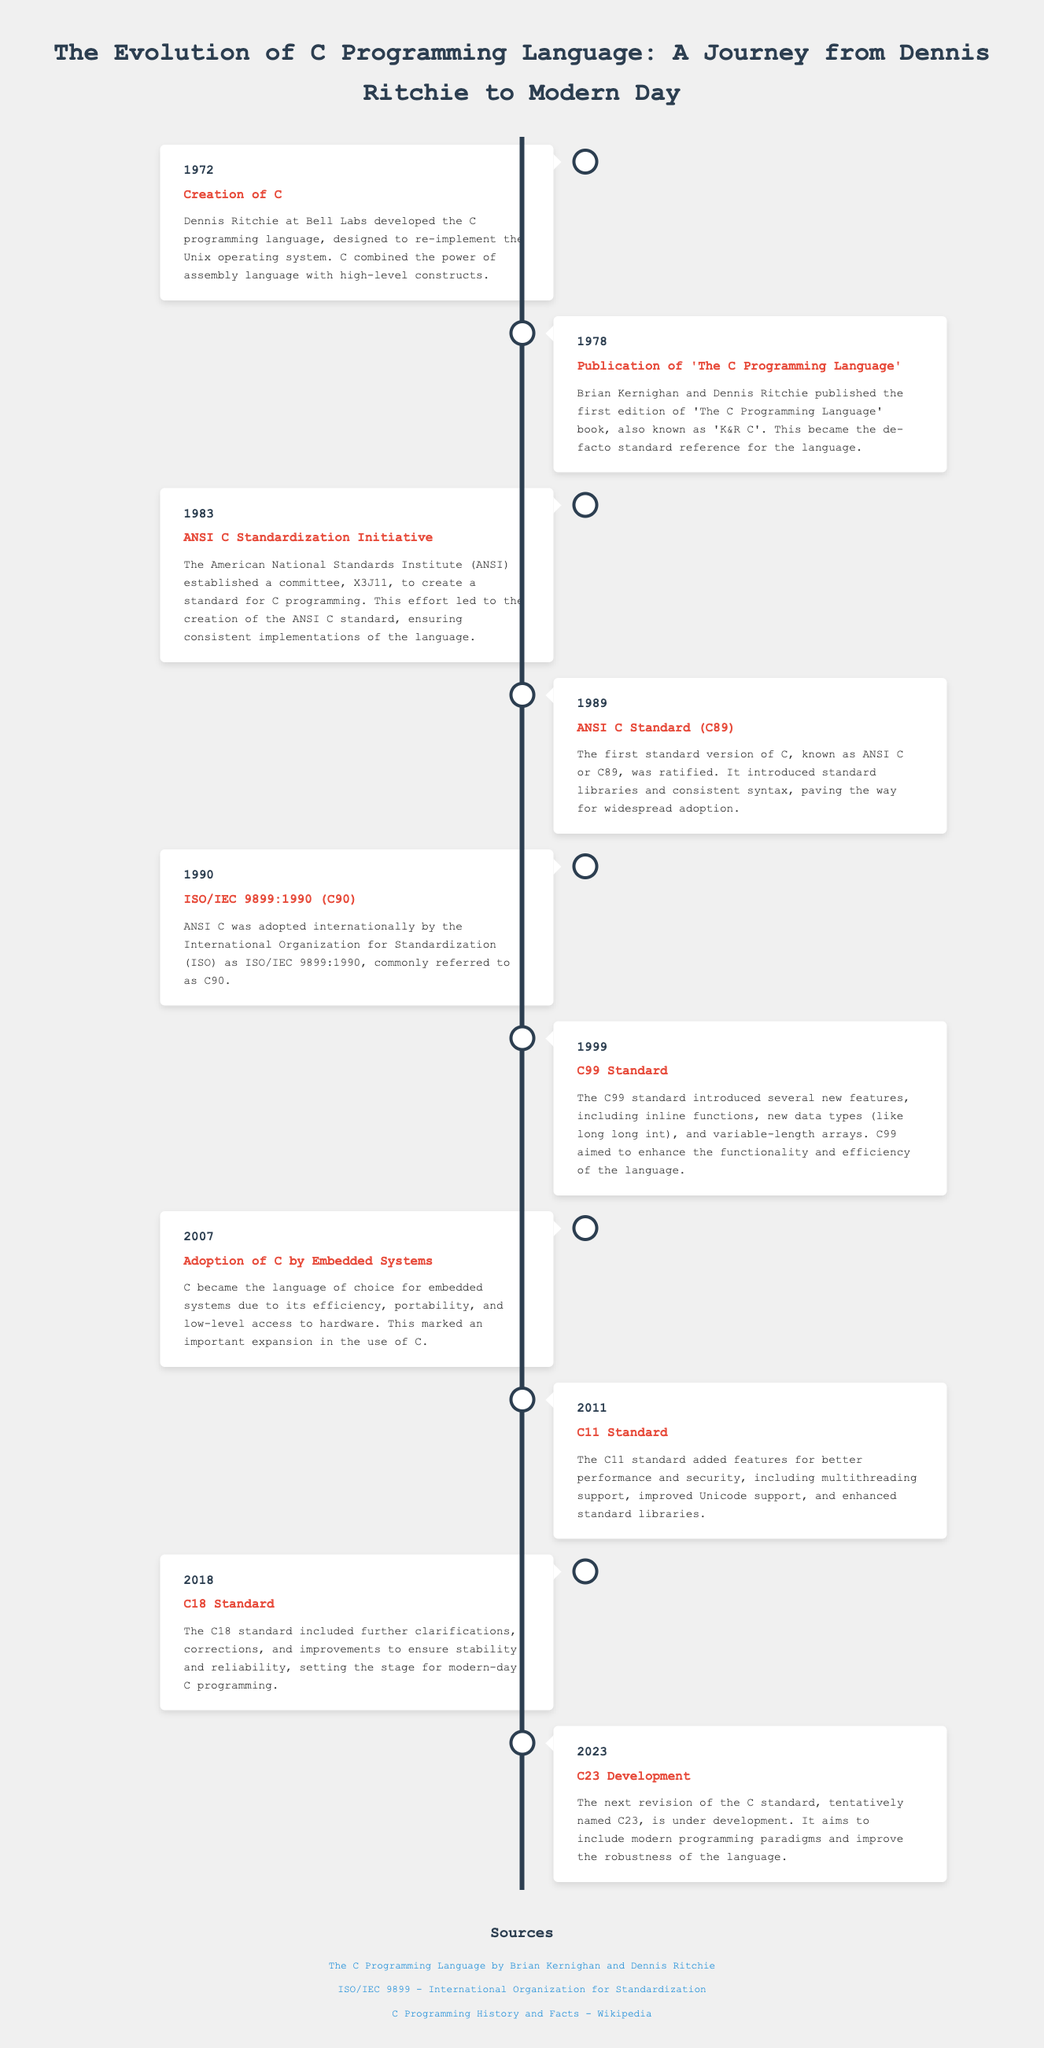What year was C created? C was created in 1972 according to the timeline.
Answer: 1972 Who developed the C programming language? The document states that Dennis Ritchie developed the C programming language at Bell Labs.
Answer: Dennis Ritchie What is the title of the book published in 1978? The timeline mentions the publication of 'The C Programming Language' in 1978.
Answer: The C Programming Language What significant standard was established in 1983? The timeline indicates that the ANSI C Standardization Initiative was established in 1983.
Answer: ANSI C Standardization Initiative What new data type was introduced in the C99 standard? The C99 standard introduced the new data type "long long int" as mentioned in the document.
Answer: long long int Which standard was ratified in 1989? The document states that the first standard version of C, known as ANSI C or C89, was ratified in 1989.
Answer: ANSI C (C89) What major feature was added in the C11 standard? According to the timeline, multithreading support was a major feature added in the C11 standard.
Answer: Multithreading support What does the term "C23" refer to? The document refers to C23 as the next revision of the C standard that is under development.
Answer: C23 What was a significant use of C mentioned in 2007? The timeline states that C became the language of choice for embedded systems in 2007.
Answer: Embedded systems 